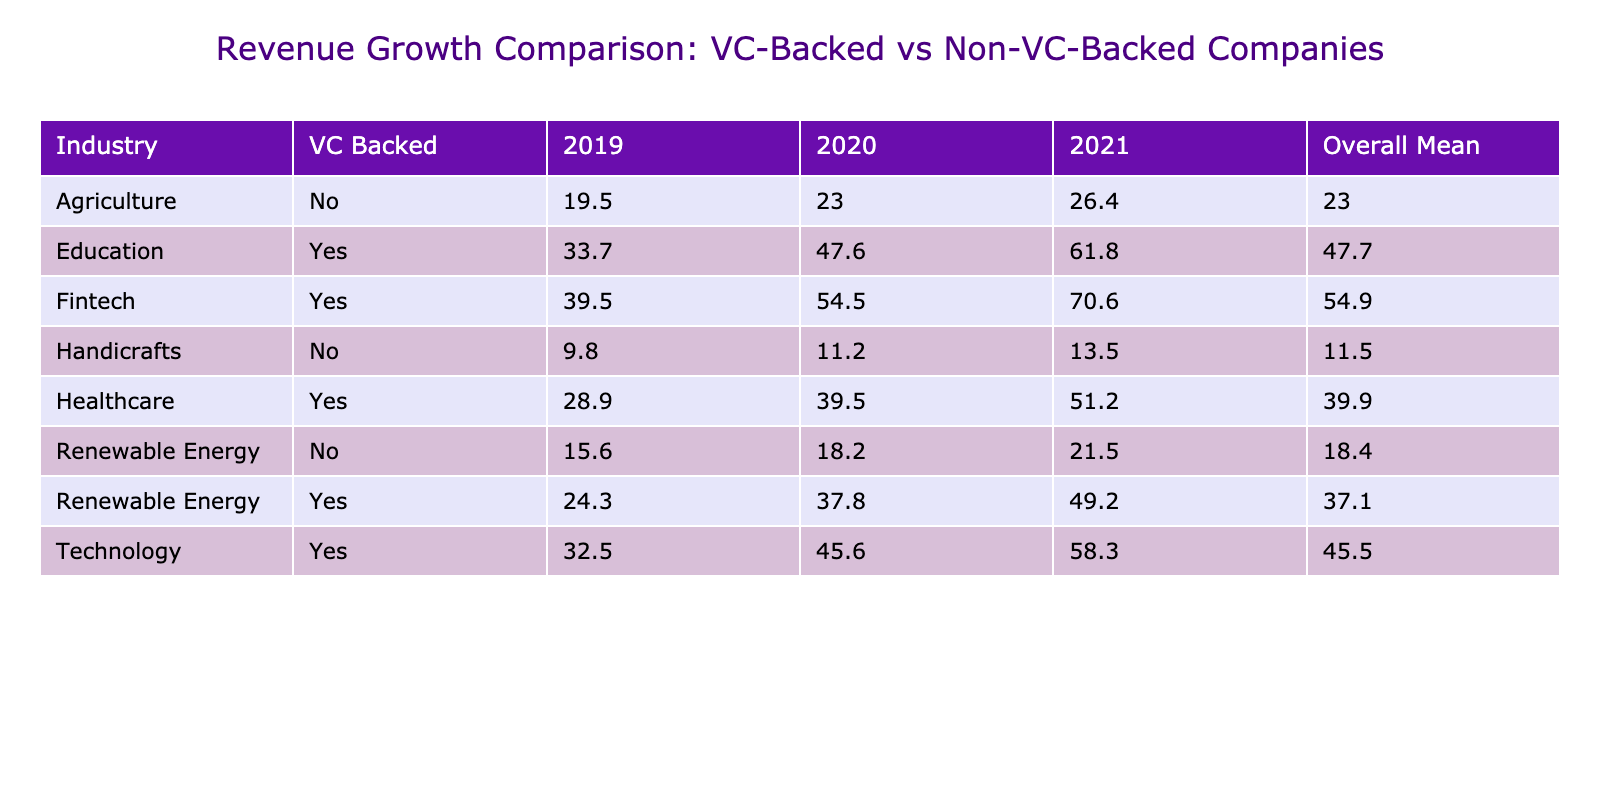What is the average revenue growth for VC-backed companies in 2019? To find the average revenue growth for VC-backed companies in 2019, I will look at the revenue growth values from the table for all VC-backed companies in that year. The values are 32.5, 24.3, 41.2, 28.9, and 37.8. The average is calculated as (32.5 + 24.3 + 41.2 + 28.9 + 37.8) / 5 = 32.574. Thus, rounding gives 32.6.
Answer: 32.6 Did LocalCraft Exports have a higher revenue growth than SunRise Solar in 2021? Looking at the values for LocalCraft Exports and SunRise Solar in 2021, LocalCraft Exports has a revenue growth of 13.5 and SunRise Solar has a revenue growth of 21.5. Since 13.5 is less than 21.5, the answer is no.
Answer: No What is the overall mean revenue growth for non-VC-backed companies across all years? First, I will find the revenue growth values for all non-VC-backed companies across the years: 18.7, 22.1, 25.6, 9.8, 11.2, 15.6, 18.2, 23.8, 21.5, 20.4, and 27.3. There are 10 data points in total. Their sum is (18.7 + 22.1 + 25.6 + 9.8 + 11.2 + 15.6 + 18.2 + 23.8 + 21.5 + 20.4 + 27.3) = 212.6. Hence, the overall mean is 212.6 / 10 = 21.26, which rounds to 21.3.
Answer: 21.3 Does EcoEnergy Africa consistently have higher revenue growth than AfriAgri Innovations across the years? To check this, I need to compare the revenue growth values year by year. In 2019, EcoEnergy Africa had 24.3, and AfriAgri Innovations had 18.7 (EcoEnergy is higher). In 2020, EcoEnergy had 37.8, and AfriAgri had 22.1 (EcoEnergy higher again). In 2021, EcoEnergy showed 49.2 while AfriAgri had 25.6 (EcoEnergy continues to be higher). Thus, EcoEnergy Africa has consistently shown higher growth than AfriAgri Innovations in all years.
Answer: Yes What was the total revenue growth of all education-related VC-backed companies in 2021? The relevant companies for education in 2021 are EduTech Africa and its revenue growth is 61.8. To find the total, I will simply sum its value (since it's the only relevant company). Thus, the total is 61.8.
Answer: 61.8 